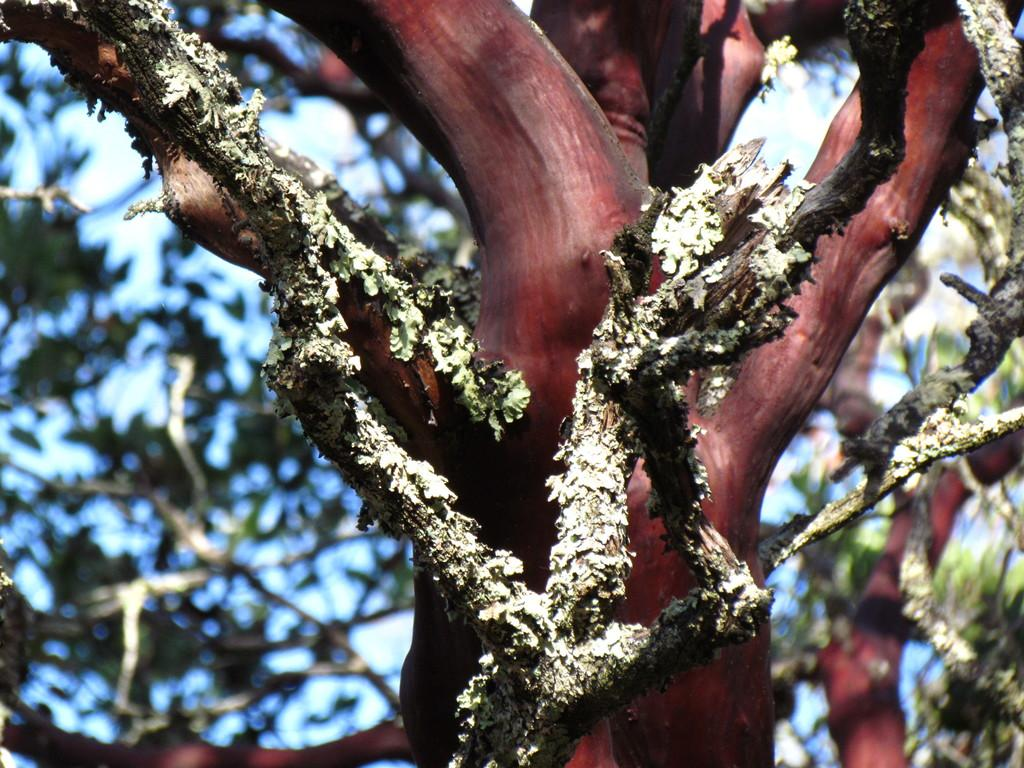What is the most prominent feature in the foreground of the image? There is a tree with a red trunk in the foreground of the image. What can be seen in the background of the image? The sky is visible in the background of the image. How many bikes are parked near the tree in the image? There are no bikes present in the image. What type of smile can be seen on the tree's face in the image? Trees do not have faces or the ability to smile, so this cannot be observed in the image. 